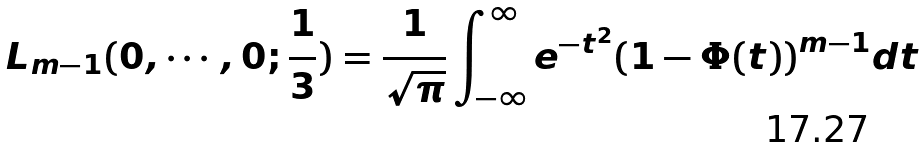<formula> <loc_0><loc_0><loc_500><loc_500>L _ { m - 1 } ( 0 , \cdots , 0 ; \frac { 1 } { 3 } ) = \frac { 1 } { \sqrt { \pi } } \int _ { - \infty } ^ { \infty } { e ^ { - t ^ { 2 } } { ( 1 - \Phi ( t ) ) } ^ { m - 1 } d t }</formula> 